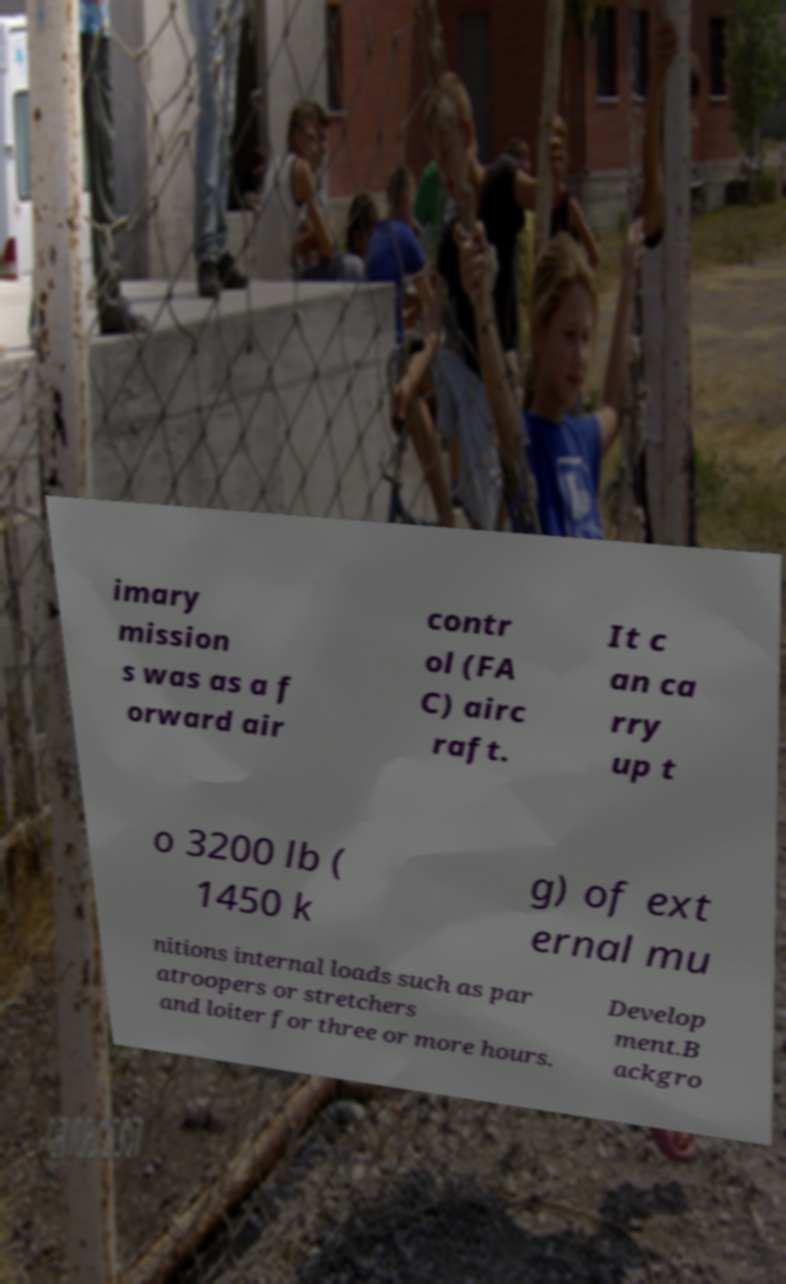What messages or text are displayed in this image? I need them in a readable, typed format. imary mission s was as a f orward air contr ol (FA C) airc raft. It c an ca rry up t o 3200 lb ( 1450 k g) of ext ernal mu nitions internal loads such as par atroopers or stretchers and loiter for three or more hours. Develop ment.B ackgro 